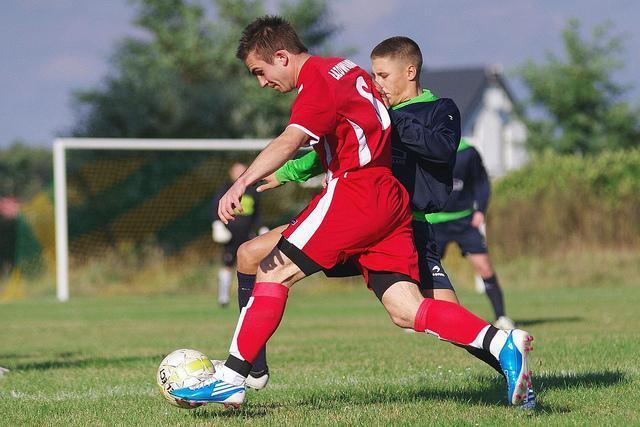How many people can you see?
Give a very brief answer. 4. 